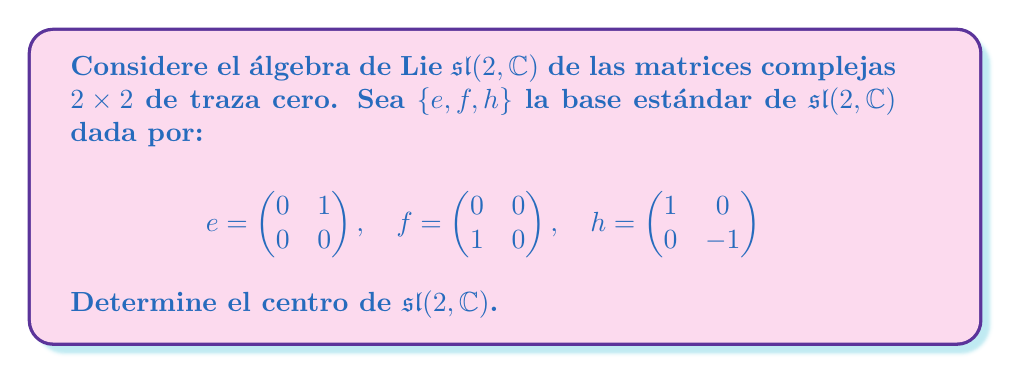What is the answer to this math problem? Para encontrar el centro de $\mathfrak{sl}(2, \mathbb{C})$, seguiremos estos pasos:

1) El centro de un álgebra de Lie se define como el conjunto de elementos que conmutan con todos los demás elementos del álgebra. En otras palabras, buscamos elementos $z$ tales que $[z, x] = 0$ para todo $x \in \mathfrak{sl}(2, \mathbb{C})$.

2) Sea $z = ae + bf + ch$ un elemento general de $\mathfrak{sl}(2, \mathbb{C})$, donde $a, b, c \in \mathbb{C}$.

3) Calculemos los conmutadores de $z$ con los elementos de la base:

   $[z, e] = [ae + bf + ch, e] = a[e,e] + b[f,e] + c[h,e] = -bh - 2ce$
   
   $[z, f] = [ae + bf + ch, f] = a[e,f] + b[f,f] + c[h,f] = ah + 2cf$
   
   $[z, h] = [ae + bf + ch, h] = a[e,h] + b[f,h] + c[h,h] = 2ae - 2bf$

4) Para que $z$ esté en el centro, todos estos conmutadores deben ser cero:

   $-bh - 2ce = 0$
   $ah + 2cf = 0$
   $2ae - 2bf = 0$

5) De estas ecuaciones, podemos deducir que $a = b = c = 0$.

6) Por lo tanto, el único elemento que conmuta con todos los demás es el elemento cero.
Answer: El centro de $\mathfrak{sl}(2, \mathbb{C})$ es $\{0\}$, es decir, consiste solo del elemento cero. 